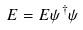<formula> <loc_0><loc_0><loc_500><loc_500>E = E \psi ^ { \dagger } \psi</formula> 